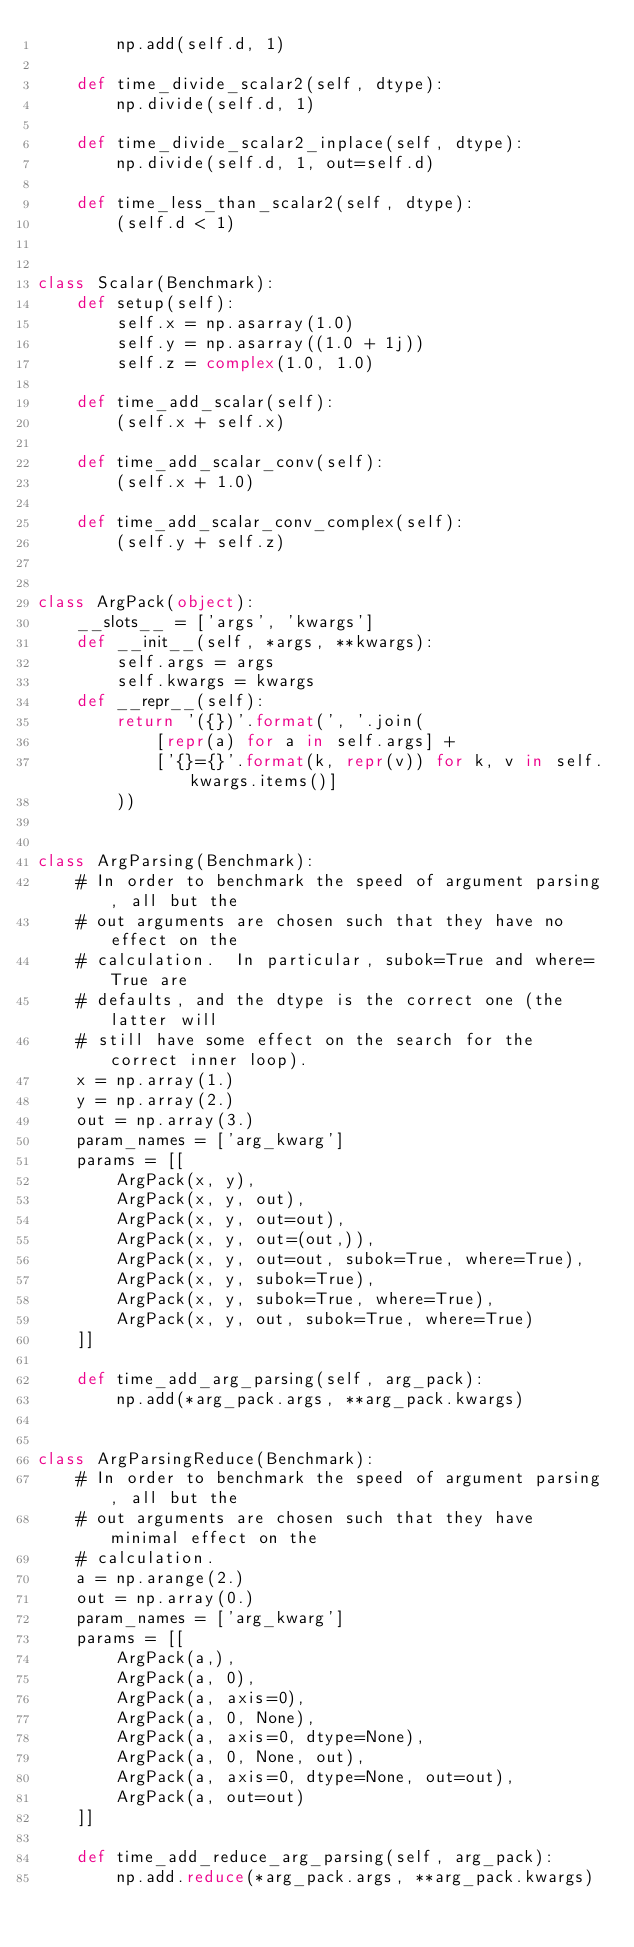<code> <loc_0><loc_0><loc_500><loc_500><_Python_>        np.add(self.d, 1)

    def time_divide_scalar2(self, dtype):
        np.divide(self.d, 1)

    def time_divide_scalar2_inplace(self, dtype):
        np.divide(self.d, 1, out=self.d)

    def time_less_than_scalar2(self, dtype):
        (self.d < 1)


class Scalar(Benchmark):
    def setup(self):
        self.x = np.asarray(1.0)
        self.y = np.asarray((1.0 + 1j))
        self.z = complex(1.0, 1.0)

    def time_add_scalar(self):
        (self.x + self.x)

    def time_add_scalar_conv(self):
        (self.x + 1.0)

    def time_add_scalar_conv_complex(self):
        (self.y + self.z)


class ArgPack(object):
    __slots__ = ['args', 'kwargs']
    def __init__(self, *args, **kwargs):
        self.args = args
        self.kwargs = kwargs
    def __repr__(self):
        return '({})'.format(', '.join(
            [repr(a) for a in self.args] +
            ['{}={}'.format(k, repr(v)) for k, v in self.kwargs.items()]
        ))


class ArgParsing(Benchmark):
    # In order to benchmark the speed of argument parsing, all but the
    # out arguments are chosen such that they have no effect on the
    # calculation.  In particular, subok=True and where=True are
    # defaults, and the dtype is the correct one (the latter will
    # still have some effect on the search for the correct inner loop).
    x = np.array(1.)
    y = np.array(2.)
    out = np.array(3.)
    param_names = ['arg_kwarg']
    params = [[
        ArgPack(x, y),
        ArgPack(x, y, out),
        ArgPack(x, y, out=out),
        ArgPack(x, y, out=(out,)),
        ArgPack(x, y, out=out, subok=True, where=True),
        ArgPack(x, y, subok=True),
        ArgPack(x, y, subok=True, where=True),
        ArgPack(x, y, out, subok=True, where=True)
    ]]

    def time_add_arg_parsing(self, arg_pack):
        np.add(*arg_pack.args, **arg_pack.kwargs)


class ArgParsingReduce(Benchmark):
    # In order to benchmark the speed of argument parsing, all but the
    # out arguments are chosen such that they have minimal effect on the
    # calculation.
    a = np.arange(2.)
    out = np.array(0.)
    param_names = ['arg_kwarg']
    params = [[
        ArgPack(a,),
        ArgPack(a, 0),
        ArgPack(a, axis=0),
        ArgPack(a, 0, None),
        ArgPack(a, axis=0, dtype=None),
        ArgPack(a, 0, None, out),
        ArgPack(a, axis=0, dtype=None, out=out),
        ArgPack(a, out=out)
    ]]

    def time_add_reduce_arg_parsing(self, arg_pack):
        np.add.reduce(*arg_pack.args, **arg_pack.kwargs)
</code> 